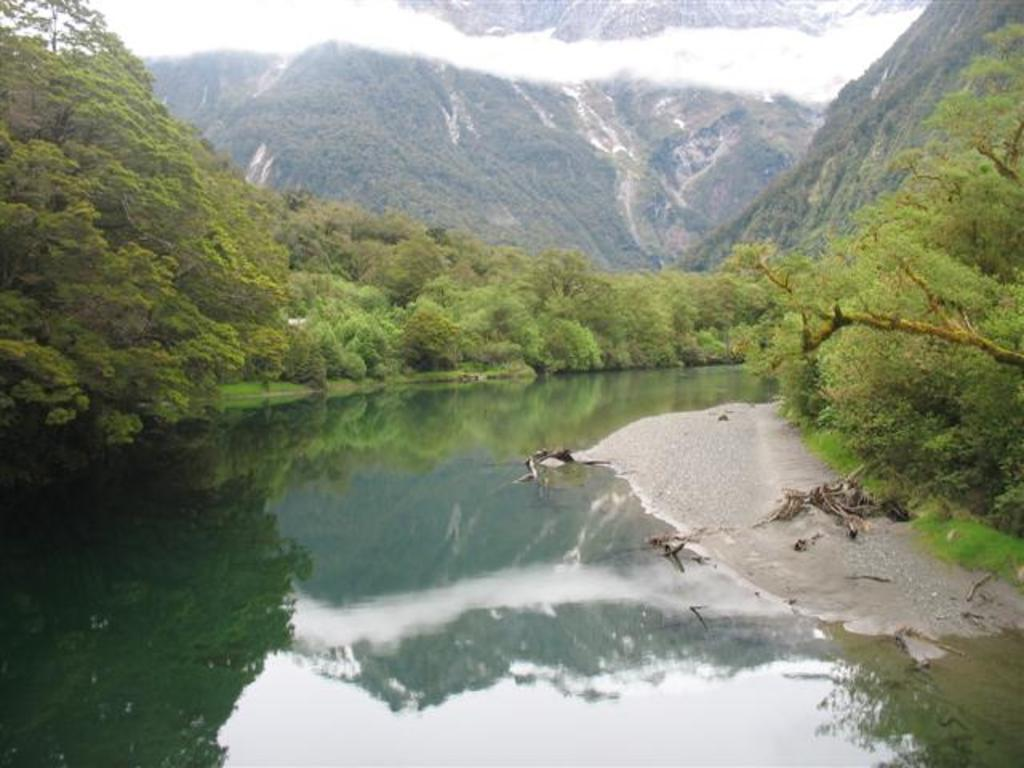What is visible in the image? Water and trees are visible in the image. What can be seen in the background of the image? There is a hill and clouds in the background of the image. What month is it in the image? The month cannot be determined from the image, as it does not contain any information about the time of year. 